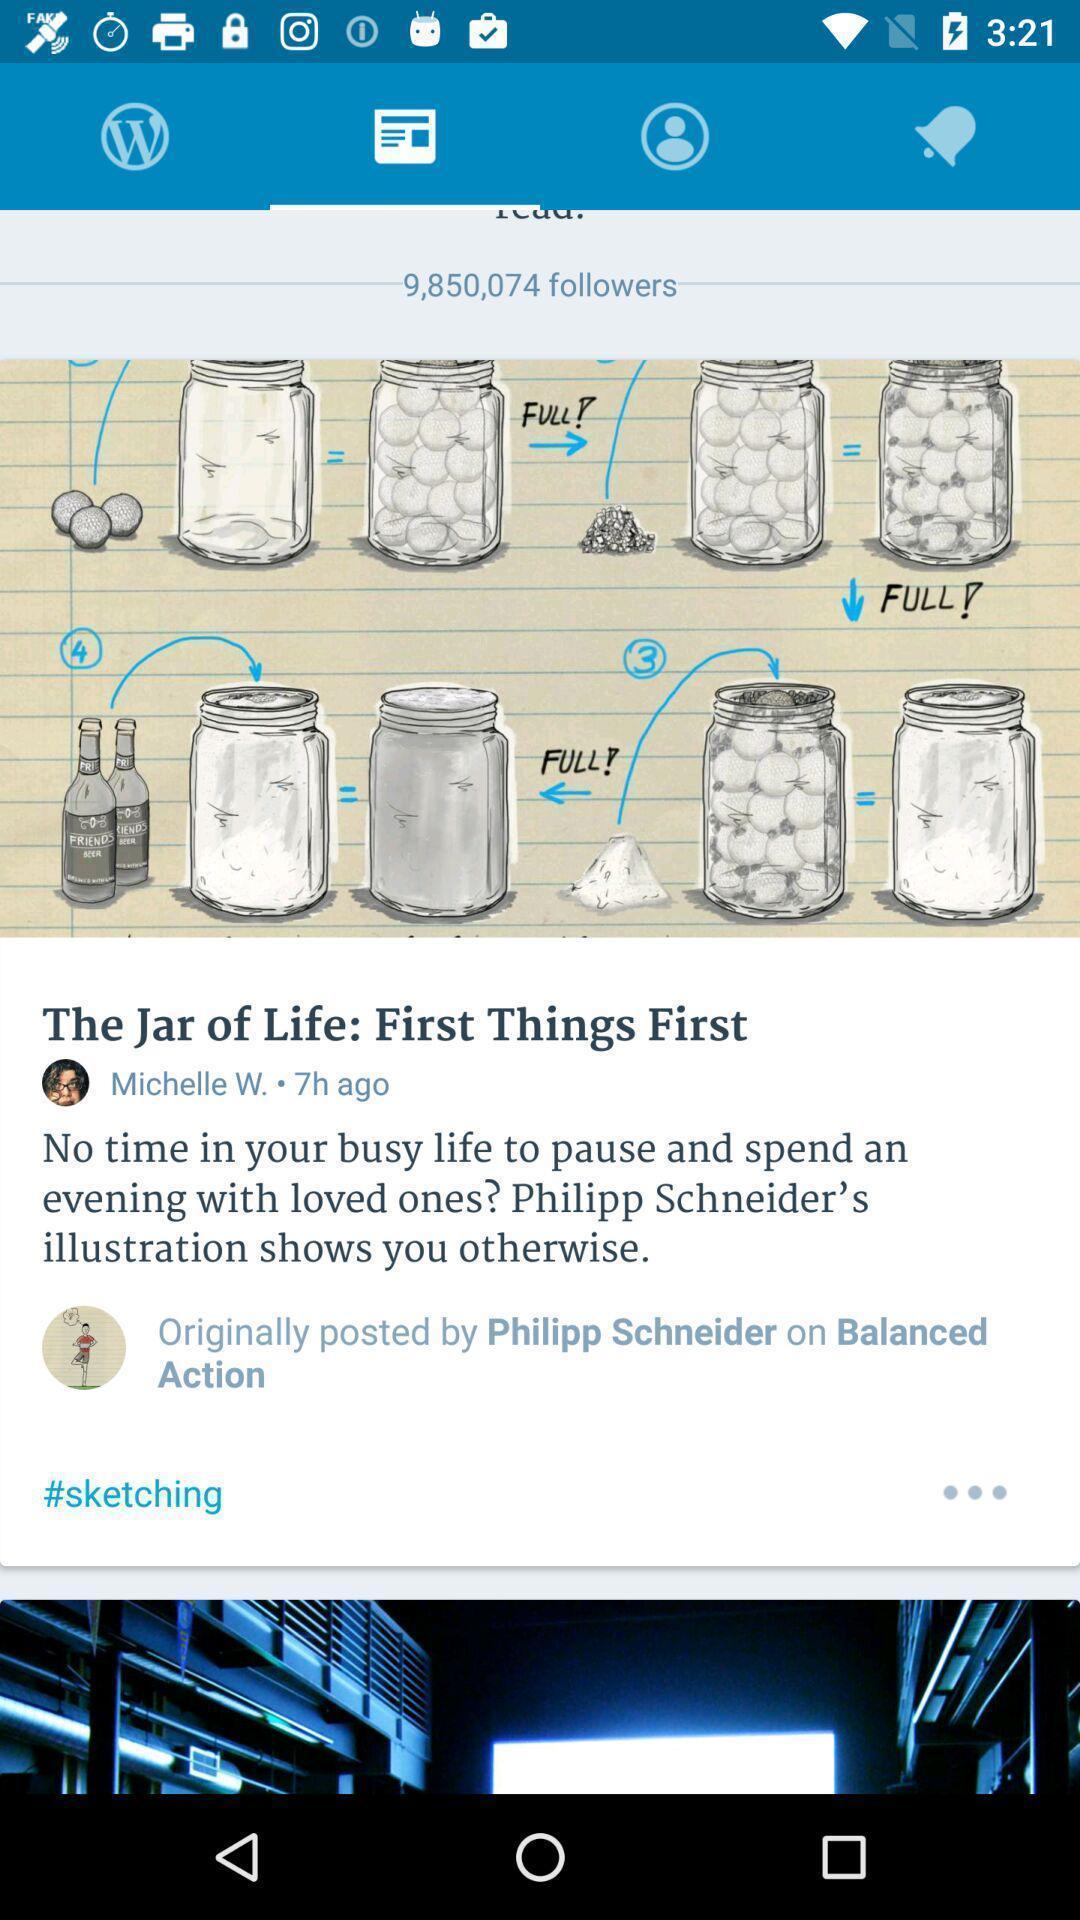Provide a detailed account of this screenshot. Screen displaying the news page. 